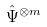Convert formula to latex. <formula><loc_0><loc_0><loc_500><loc_500>\hat { \Psi } ^ { \otimes m }</formula> 